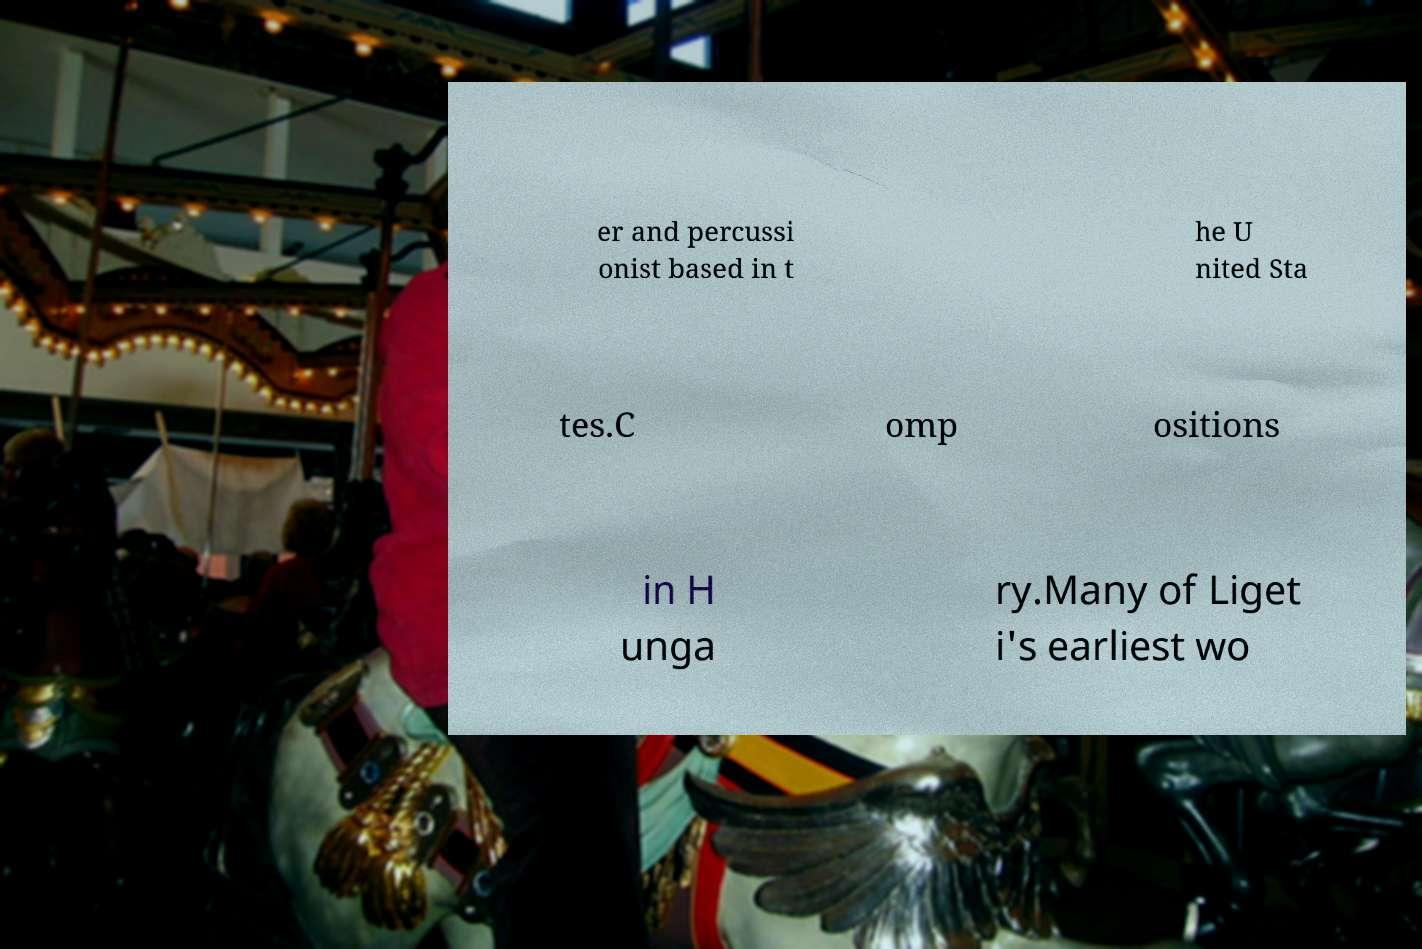Please read and relay the text visible in this image. What does it say? er and percussi onist based in t he U nited Sta tes.C omp ositions in H unga ry.Many of Liget i's earliest wo 